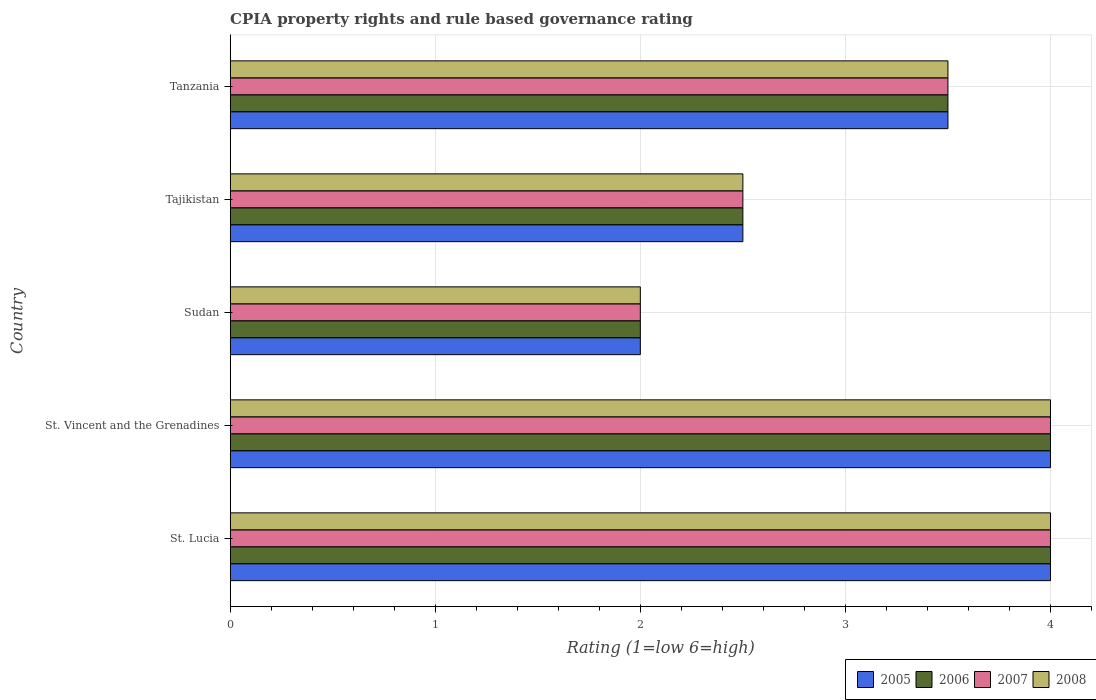Are the number of bars per tick equal to the number of legend labels?
Provide a short and direct response. Yes. Are the number of bars on each tick of the Y-axis equal?
Your response must be concise. Yes. How many bars are there on the 3rd tick from the top?
Offer a very short reply. 4. What is the label of the 3rd group of bars from the top?
Make the answer very short. Sudan. In how many cases, is the number of bars for a given country not equal to the number of legend labels?
Give a very brief answer. 0. Across all countries, what is the maximum CPIA rating in 2005?
Give a very brief answer. 4. In which country was the CPIA rating in 2008 maximum?
Offer a terse response. St. Lucia. In which country was the CPIA rating in 2006 minimum?
Provide a succinct answer. Sudan. What is the total CPIA rating in 2005 in the graph?
Ensure brevity in your answer.  16. What is the difference between the CPIA rating in 2008 and CPIA rating in 2007 in Sudan?
Your answer should be compact. 0. In how many countries, is the CPIA rating in 2006 greater than 0.6000000000000001 ?
Provide a succinct answer. 5. Is the CPIA rating in 2005 in St. Vincent and the Grenadines less than that in Tanzania?
Offer a terse response. No. Is the difference between the CPIA rating in 2008 in St. Vincent and the Grenadines and Sudan greater than the difference between the CPIA rating in 2007 in St. Vincent and the Grenadines and Sudan?
Ensure brevity in your answer.  No. What is the difference between the highest and the second highest CPIA rating in 2005?
Your answer should be very brief. 0. What is the difference between the highest and the lowest CPIA rating in 2007?
Keep it short and to the point. 2. In how many countries, is the CPIA rating in 2006 greater than the average CPIA rating in 2006 taken over all countries?
Your response must be concise. 3. Is the sum of the CPIA rating in 2007 in Tajikistan and Tanzania greater than the maximum CPIA rating in 2005 across all countries?
Make the answer very short. Yes. Is it the case that in every country, the sum of the CPIA rating in 2007 and CPIA rating in 2006 is greater than the sum of CPIA rating in 2005 and CPIA rating in 2008?
Ensure brevity in your answer.  No. What does the 3rd bar from the bottom in Tanzania represents?
Provide a succinct answer. 2007. How many bars are there?
Offer a very short reply. 20. Are all the bars in the graph horizontal?
Offer a very short reply. Yes. What is the difference between two consecutive major ticks on the X-axis?
Your response must be concise. 1. Does the graph contain any zero values?
Offer a terse response. No. How are the legend labels stacked?
Ensure brevity in your answer.  Horizontal. What is the title of the graph?
Make the answer very short. CPIA property rights and rule based governance rating. Does "1960" appear as one of the legend labels in the graph?
Give a very brief answer. No. What is the label or title of the X-axis?
Make the answer very short. Rating (1=low 6=high). What is the Rating (1=low 6=high) of 2005 in St. Lucia?
Offer a terse response. 4. What is the Rating (1=low 6=high) of 2005 in St. Vincent and the Grenadines?
Your answer should be compact. 4. What is the Rating (1=low 6=high) of 2007 in St. Vincent and the Grenadines?
Make the answer very short. 4. What is the Rating (1=low 6=high) of 2008 in St. Vincent and the Grenadines?
Your response must be concise. 4. What is the Rating (1=low 6=high) of 2005 in Sudan?
Provide a short and direct response. 2. What is the Rating (1=low 6=high) in 2007 in Sudan?
Offer a very short reply. 2. What is the Rating (1=low 6=high) in 2005 in Tajikistan?
Your response must be concise. 2.5. What is the Rating (1=low 6=high) in 2006 in Tajikistan?
Make the answer very short. 2.5. What is the Rating (1=low 6=high) of 2007 in Tajikistan?
Give a very brief answer. 2.5. What is the Rating (1=low 6=high) in 2008 in Tajikistan?
Your response must be concise. 2.5. What is the Rating (1=low 6=high) of 2006 in Tanzania?
Provide a short and direct response. 3.5. What is the Rating (1=low 6=high) of 2008 in Tanzania?
Your answer should be very brief. 3.5. Across all countries, what is the maximum Rating (1=low 6=high) of 2005?
Ensure brevity in your answer.  4. Across all countries, what is the maximum Rating (1=low 6=high) of 2006?
Offer a terse response. 4. Across all countries, what is the maximum Rating (1=low 6=high) of 2007?
Your response must be concise. 4. Across all countries, what is the maximum Rating (1=low 6=high) in 2008?
Your answer should be very brief. 4. Across all countries, what is the minimum Rating (1=low 6=high) of 2006?
Offer a terse response. 2. Across all countries, what is the minimum Rating (1=low 6=high) of 2007?
Make the answer very short. 2. What is the total Rating (1=low 6=high) in 2006 in the graph?
Make the answer very short. 16. What is the total Rating (1=low 6=high) of 2008 in the graph?
Provide a succinct answer. 16. What is the difference between the Rating (1=low 6=high) of 2006 in St. Lucia and that in St. Vincent and the Grenadines?
Your answer should be very brief. 0. What is the difference between the Rating (1=low 6=high) of 2007 in St. Lucia and that in St. Vincent and the Grenadines?
Provide a short and direct response. 0. What is the difference between the Rating (1=low 6=high) in 2006 in St. Lucia and that in Sudan?
Your answer should be compact. 2. What is the difference between the Rating (1=low 6=high) in 2008 in St. Lucia and that in Sudan?
Your response must be concise. 2. What is the difference between the Rating (1=low 6=high) in 2005 in St. Lucia and that in Tajikistan?
Provide a short and direct response. 1.5. What is the difference between the Rating (1=low 6=high) in 2006 in St. Lucia and that in Tajikistan?
Offer a very short reply. 1.5. What is the difference between the Rating (1=low 6=high) in 2007 in St. Lucia and that in Tajikistan?
Provide a succinct answer. 1.5. What is the difference between the Rating (1=low 6=high) in 2007 in St. Lucia and that in Tanzania?
Your answer should be very brief. 0.5. What is the difference between the Rating (1=low 6=high) of 2008 in St. Lucia and that in Tanzania?
Your answer should be compact. 0.5. What is the difference between the Rating (1=low 6=high) in 2006 in St. Vincent and the Grenadines and that in Sudan?
Keep it short and to the point. 2. What is the difference between the Rating (1=low 6=high) of 2008 in St. Vincent and the Grenadines and that in Sudan?
Offer a very short reply. 2. What is the difference between the Rating (1=low 6=high) in 2005 in St. Vincent and the Grenadines and that in Tajikistan?
Your response must be concise. 1.5. What is the difference between the Rating (1=low 6=high) of 2007 in St. Vincent and the Grenadines and that in Tajikistan?
Keep it short and to the point. 1.5. What is the difference between the Rating (1=low 6=high) in 2005 in St. Vincent and the Grenadines and that in Tanzania?
Keep it short and to the point. 0.5. What is the difference between the Rating (1=low 6=high) in 2007 in St. Vincent and the Grenadines and that in Tanzania?
Give a very brief answer. 0.5. What is the difference between the Rating (1=low 6=high) in 2006 in Sudan and that in Tajikistan?
Your answer should be compact. -0.5. What is the difference between the Rating (1=low 6=high) of 2007 in Sudan and that in Tajikistan?
Your response must be concise. -0.5. What is the difference between the Rating (1=low 6=high) of 2008 in Sudan and that in Tajikistan?
Provide a short and direct response. -0.5. What is the difference between the Rating (1=low 6=high) in 2006 in Sudan and that in Tanzania?
Ensure brevity in your answer.  -1.5. What is the difference between the Rating (1=low 6=high) in 2007 in Sudan and that in Tanzania?
Ensure brevity in your answer.  -1.5. What is the difference between the Rating (1=low 6=high) in 2005 in Tajikistan and that in Tanzania?
Your answer should be very brief. -1. What is the difference between the Rating (1=low 6=high) in 2007 in Tajikistan and that in Tanzania?
Make the answer very short. -1. What is the difference between the Rating (1=low 6=high) of 2005 in St. Lucia and the Rating (1=low 6=high) of 2006 in St. Vincent and the Grenadines?
Ensure brevity in your answer.  0. What is the difference between the Rating (1=low 6=high) in 2005 in St. Lucia and the Rating (1=low 6=high) in 2007 in St. Vincent and the Grenadines?
Offer a terse response. 0. What is the difference between the Rating (1=low 6=high) of 2006 in St. Lucia and the Rating (1=low 6=high) of 2007 in St. Vincent and the Grenadines?
Provide a succinct answer. 0. What is the difference between the Rating (1=low 6=high) in 2006 in St. Lucia and the Rating (1=low 6=high) in 2008 in St. Vincent and the Grenadines?
Provide a succinct answer. 0. What is the difference between the Rating (1=low 6=high) in 2007 in St. Lucia and the Rating (1=low 6=high) in 2008 in St. Vincent and the Grenadines?
Provide a short and direct response. 0. What is the difference between the Rating (1=low 6=high) of 2005 in St. Lucia and the Rating (1=low 6=high) of 2006 in Sudan?
Give a very brief answer. 2. What is the difference between the Rating (1=low 6=high) in 2005 in St. Lucia and the Rating (1=low 6=high) in 2007 in Sudan?
Your answer should be very brief. 2. What is the difference between the Rating (1=low 6=high) in 2006 in St. Lucia and the Rating (1=low 6=high) in 2008 in Sudan?
Give a very brief answer. 2. What is the difference between the Rating (1=low 6=high) in 2007 in St. Lucia and the Rating (1=low 6=high) in 2008 in Sudan?
Give a very brief answer. 2. What is the difference between the Rating (1=low 6=high) in 2005 in St. Lucia and the Rating (1=low 6=high) in 2006 in Tajikistan?
Offer a terse response. 1.5. What is the difference between the Rating (1=low 6=high) in 2005 in St. Lucia and the Rating (1=low 6=high) in 2008 in Tajikistan?
Provide a succinct answer. 1.5. What is the difference between the Rating (1=low 6=high) in 2005 in St. Lucia and the Rating (1=low 6=high) in 2006 in Tanzania?
Ensure brevity in your answer.  0.5. What is the difference between the Rating (1=low 6=high) in 2005 in St. Lucia and the Rating (1=low 6=high) in 2007 in Tanzania?
Provide a short and direct response. 0.5. What is the difference between the Rating (1=low 6=high) in 2005 in St. Lucia and the Rating (1=low 6=high) in 2008 in Tanzania?
Ensure brevity in your answer.  0.5. What is the difference between the Rating (1=low 6=high) in 2006 in St. Lucia and the Rating (1=low 6=high) in 2007 in Tanzania?
Your answer should be very brief. 0.5. What is the difference between the Rating (1=low 6=high) in 2005 in St. Vincent and the Grenadines and the Rating (1=low 6=high) in 2006 in Sudan?
Provide a short and direct response. 2. What is the difference between the Rating (1=low 6=high) of 2006 in St. Vincent and the Grenadines and the Rating (1=low 6=high) of 2007 in Sudan?
Your response must be concise. 2. What is the difference between the Rating (1=low 6=high) of 2006 in St. Vincent and the Grenadines and the Rating (1=low 6=high) of 2008 in Sudan?
Your answer should be very brief. 2. What is the difference between the Rating (1=low 6=high) of 2007 in St. Vincent and the Grenadines and the Rating (1=low 6=high) of 2008 in Sudan?
Make the answer very short. 2. What is the difference between the Rating (1=low 6=high) of 2005 in St. Vincent and the Grenadines and the Rating (1=low 6=high) of 2006 in Tajikistan?
Ensure brevity in your answer.  1.5. What is the difference between the Rating (1=low 6=high) of 2007 in St. Vincent and the Grenadines and the Rating (1=low 6=high) of 2008 in Tajikistan?
Provide a short and direct response. 1.5. What is the difference between the Rating (1=low 6=high) in 2007 in St. Vincent and the Grenadines and the Rating (1=low 6=high) in 2008 in Tanzania?
Your answer should be very brief. 0.5. What is the difference between the Rating (1=low 6=high) of 2005 in Sudan and the Rating (1=low 6=high) of 2006 in Tajikistan?
Your answer should be very brief. -0.5. What is the difference between the Rating (1=low 6=high) of 2005 in Sudan and the Rating (1=low 6=high) of 2008 in Tajikistan?
Provide a succinct answer. -0.5. What is the difference between the Rating (1=low 6=high) of 2005 in Sudan and the Rating (1=low 6=high) of 2007 in Tanzania?
Your response must be concise. -1.5. What is the difference between the Rating (1=low 6=high) of 2005 in Sudan and the Rating (1=low 6=high) of 2008 in Tanzania?
Offer a terse response. -1.5. What is the difference between the Rating (1=low 6=high) of 2006 in Sudan and the Rating (1=low 6=high) of 2008 in Tanzania?
Your answer should be very brief. -1.5. What is the difference between the Rating (1=low 6=high) in 2007 in Sudan and the Rating (1=low 6=high) in 2008 in Tanzania?
Give a very brief answer. -1.5. What is the difference between the Rating (1=low 6=high) of 2005 in Tajikistan and the Rating (1=low 6=high) of 2008 in Tanzania?
Your answer should be very brief. -1. What is the difference between the Rating (1=low 6=high) in 2006 in Tajikistan and the Rating (1=low 6=high) in 2008 in Tanzania?
Your answer should be compact. -1. What is the difference between the Rating (1=low 6=high) in 2007 in Tajikistan and the Rating (1=low 6=high) in 2008 in Tanzania?
Your answer should be compact. -1. What is the average Rating (1=low 6=high) of 2008 per country?
Your answer should be compact. 3.2. What is the difference between the Rating (1=low 6=high) in 2005 and Rating (1=low 6=high) in 2006 in St. Lucia?
Ensure brevity in your answer.  0. What is the difference between the Rating (1=low 6=high) in 2007 and Rating (1=low 6=high) in 2008 in St. Lucia?
Provide a succinct answer. 0. What is the difference between the Rating (1=low 6=high) in 2005 and Rating (1=low 6=high) in 2006 in St. Vincent and the Grenadines?
Give a very brief answer. 0. What is the difference between the Rating (1=low 6=high) of 2006 and Rating (1=low 6=high) of 2007 in St. Vincent and the Grenadines?
Your answer should be compact. 0. What is the difference between the Rating (1=low 6=high) of 2005 and Rating (1=low 6=high) of 2007 in Sudan?
Provide a succinct answer. 0. What is the difference between the Rating (1=low 6=high) in 2005 and Rating (1=low 6=high) in 2008 in Sudan?
Ensure brevity in your answer.  0. What is the difference between the Rating (1=low 6=high) in 2006 and Rating (1=low 6=high) in 2007 in Sudan?
Your answer should be very brief. 0. What is the difference between the Rating (1=low 6=high) of 2006 and Rating (1=low 6=high) of 2008 in Sudan?
Give a very brief answer. 0. What is the difference between the Rating (1=low 6=high) of 2007 and Rating (1=low 6=high) of 2008 in Sudan?
Your answer should be compact. 0. What is the difference between the Rating (1=low 6=high) of 2005 and Rating (1=low 6=high) of 2006 in Tajikistan?
Ensure brevity in your answer.  0. What is the difference between the Rating (1=low 6=high) in 2005 and Rating (1=low 6=high) in 2007 in Tajikistan?
Ensure brevity in your answer.  0. What is the difference between the Rating (1=low 6=high) in 2005 and Rating (1=low 6=high) in 2008 in Tajikistan?
Provide a succinct answer. 0. What is the difference between the Rating (1=low 6=high) in 2006 and Rating (1=low 6=high) in 2007 in Tajikistan?
Provide a succinct answer. 0. What is the difference between the Rating (1=low 6=high) in 2006 and Rating (1=low 6=high) in 2008 in Tajikistan?
Your answer should be compact. 0. What is the difference between the Rating (1=low 6=high) in 2007 and Rating (1=low 6=high) in 2008 in Tajikistan?
Make the answer very short. 0. What is the difference between the Rating (1=low 6=high) of 2006 and Rating (1=low 6=high) of 2007 in Tanzania?
Provide a short and direct response. 0. What is the difference between the Rating (1=low 6=high) of 2007 and Rating (1=low 6=high) of 2008 in Tanzania?
Your answer should be compact. 0. What is the ratio of the Rating (1=low 6=high) in 2005 in St. Lucia to that in St. Vincent and the Grenadines?
Offer a terse response. 1. What is the ratio of the Rating (1=low 6=high) in 2006 in St. Lucia to that in St. Vincent and the Grenadines?
Offer a terse response. 1. What is the ratio of the Rating (1=low 6=high) of 2008 in St. Lucia to that in St. Vincent and the Grenadines?
Give a very brief answer. 1. What is the ratio of the Rating (1=low 6=high) of 2006 in St. Lucia to that in Sudan?
Ensure brevity in your answer.  2. What is the ratio of the Rating (1=low 6=high) of 2007 in St. Lucia to that in Sudan?
Offer a very short reply. 2. What is the ratio of the Rating (1=low 6=high) of 2005 in St. Lucia to that in Tajikistan?
Offer a terse response. 1.6. What is the ratio of the Rating (1=low 6=high) in 2008 in St. Lucia to that in Tajikistan?
Keep it short and to the point. 1.6. What is the ratio of the Rating (1=low 6=high) in 2005 in St. Lucia to that in Tanzania?
Offer a terse response. 1.14. What is the ratio of the Rating (1=low 6=high) of 2008 in St. Lucia to that in Tanzania?
Your answer should be very brief. 1.14. What is the ratio of the Rating (1=low 6=high) of 2007 in St. Vincent and the Grenadines to that in Sudan?
Ensure brevity in your answer.  2. What is the ratio of the Rating (1=low 6=high) in 2008 in St. Vincent and the Grenadines to that in Sudan?
Keep it short and to the point. 2. What is the ratio of the Rating (1=low 6=high) of 2005 in St. Vincent and the Grenadines to that in Tajikistan?
Offer a very short reply. 1.6. What is the ratio of the Rating (1=low 6=high) in 2006 in St. Vincent and the Grenadines to that in Tajikistan?
Your answer should be compact. 1.6. What is the ratio of the Rating (1=low 6=high) in 2005 in St. Vincent and the Grenadines to that in Tanzania?
Your answer should be very brief. 1.14. What is the ratio of the Rating (1=low 6=high) in 2005 in Sudan to that in Tajikistan?
Make the answer very short. 0.8. What is the ratio of the Rating (1=low 6=high) in 2007 in Sudan to that in Tajikistan?
Ensure brevity in your answer.  0.8. What is the ratio of the Rating (1=low 6=high) of 2008 in Sudan to that in Tajikistan?
Make the answer very short. 0.8. What is the ratio of the Rating (1=low 6=high) in 2005 in Sudan to that in Tanzania?
Give a very brief answer. 0.57. What is the ratio of the Rating (1=low 6=high) of 2007 in Sudan to that in Tanzania?
Keep it short and to the point. 0.57. What is the ratio of the Rating (1=low 6=high) of 2005 in Tajikistan to that in Tanzania?
Your answer should be very brief. 0.71. What is the ratio of the Rating (1=low 6=high) in 2007 in Tajikistan to that in Tanzania?
Offer a very short reply. 0.71. What is the difference between the highest and the second highest Rating (1=low 6=high) of 2005?
Provide a succinct answer. 0. What is the difference between the highest and the second highest Rating (1=low 6=high) in 2006?
Offer a terse response. 0. What is the difference between the highest and the second highest Rating (1=low 6=high) of 2007?
Offer a terse response. 0. What is the difference between the highest and the second highest Rating (1=low 6=high) in 2008?
Provide a short and direct response. 0. What is the difference between the highest and the lowest Rating (1=low 6=high) in 2005?
Your response must be concise. 2. 